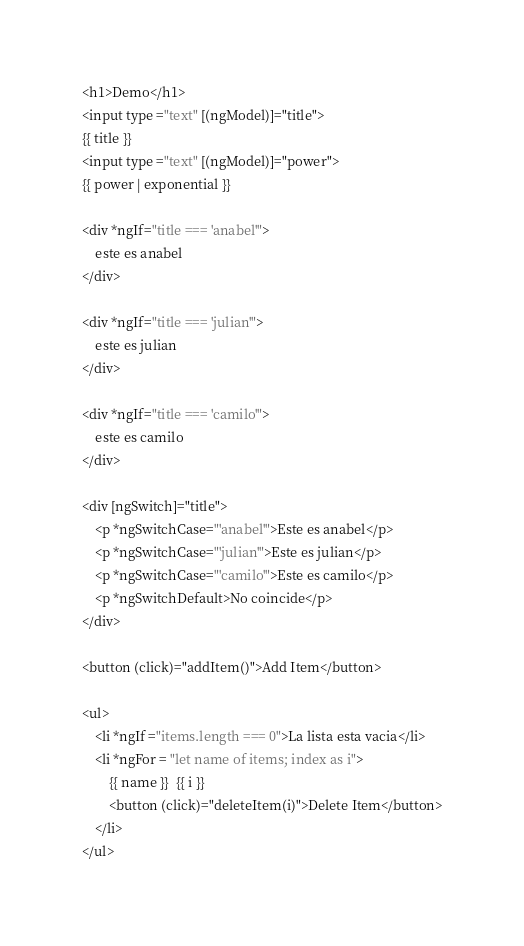Convert code to text. <code><loc_0><loc_0><loc_500><loc_500><_HTML_><h1>Demo</h1>
<input type ="text" [(ngModel)]="title">
{{ title }}
<input type ="text" [(ngModel)]="power">
{{ power | exponential }}

<div *ngIf="title === 'anabel'">
    este es anabel
</div>

<div *ngIf="title === 'julian'">
    este es julian
</div>

<div *ngIf="title === 'camilo'">
    este es camilo
</div>

<div [ngSwitch]="title">
    <p *ngSwitchCase="'anabel'">Este es anabel</p>
    <p *ngSwitchCase="'julian'">Este es julian</p>
    <p *ngSwitchCase="'camilo'">Este es camilo</p>
    <p *ngSwitchDefault>No coincide</p>
</div>

<button (click)="addItem()">Add Item</button>

<ul>
    <li *ngIf ="items.length === 0">La lista esta vacia</li>
    <li *ngFor = "let name of items; index as i">
        {{ name }}  {{ i }}
        <button (click)="deleteItem(i)">Delete Item</button>
    </li>
</ul></code> 